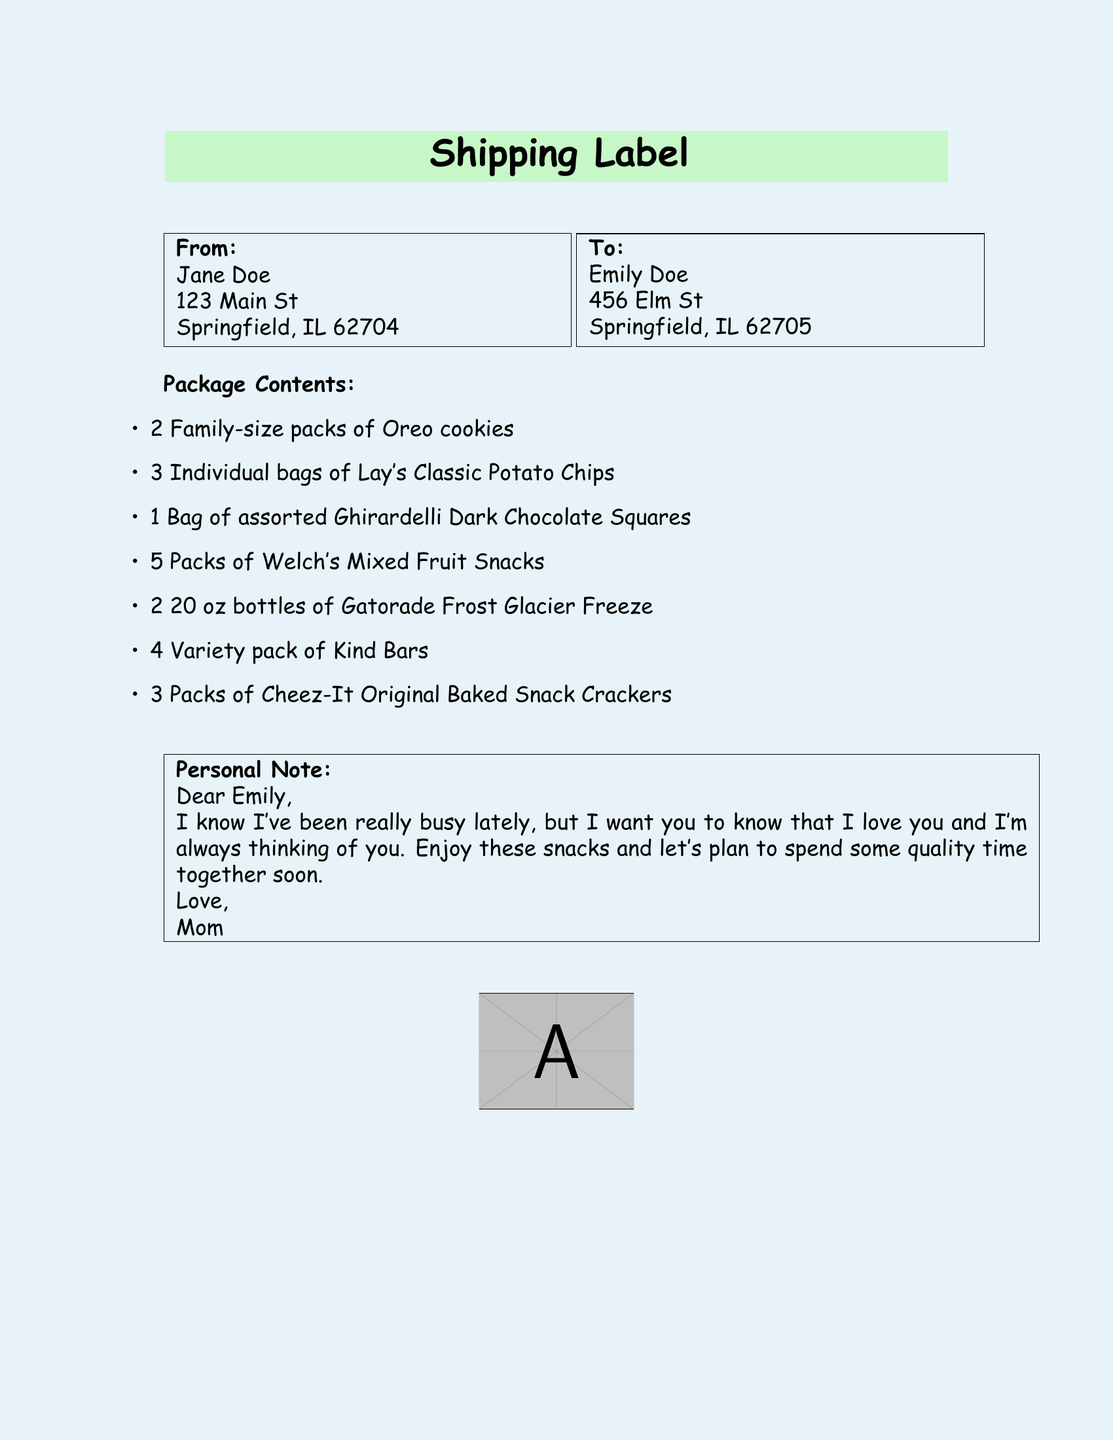What is the sender's name? The sender's name is listed under the "From" section of the document.
Answer: Jane Doe What is the recipient's address? The recipient's address is found under the "To" section of the document.
Answer: 456 Elm St, Springfield, IL 62705 How many packs of Oreo cookies are included? The number of Oreo cookie packs is specified in the package contents list.
Answer: 2 Family-size packs What is the total number of different snack items listed? The total number of different snack items can be counted from the package contents section.
Answer: 7 What does the personal note express? The personal note conveys the sender's feelings and intentions, reflecting a desire for connection.
Answer: Love and intention to spend time together Which drink is included in the package? The drink included in the package is mentioned under the package contents.
Answer: Gatorade Frost Glacier Freeze What type of document is this? The overall structure and labeling in the document indicate its format and purpose.
Answer: Shipping label Who is the note addressed to? The note in the package specifies the person it is directed towards.
Answer: Emily 